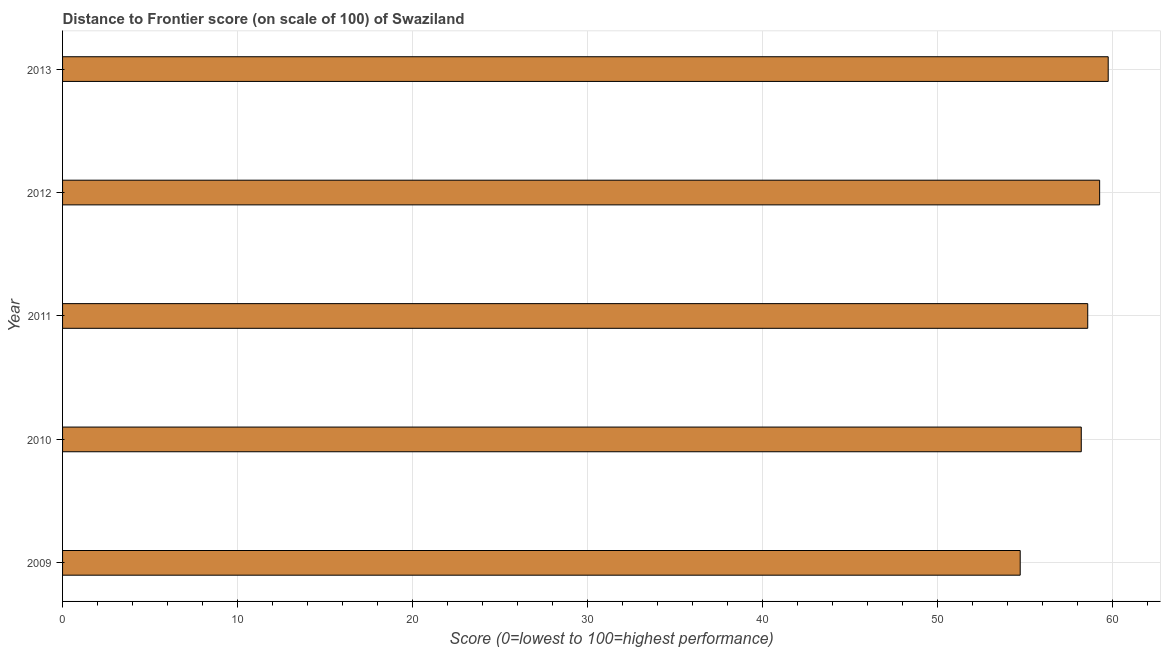Does the graph contain any zero values?
Make the answer very short. No. Does the graph contain grids?
Ensure brevity in your answer.  Yes. What is the title of the graph?
Provide a short and direct response. Distance to Frontier score (on scale of 100) of Swaziland. What is the label or title of the X-axis?
Provide a short and direct response. Score (0=lowest to 100=highest performance). What is the distance to frontier score in 2013?
Make the answer very short. 59.76. Across all years, what is the maximum distance to frontier score?
Offer a terse response. 59.76. Across all years, what is the minimum distance to frontier score?
Give a very brief answer. 54.73. In which year was the distance to frontier score maximum?
Your answer should be very brief. 2013. In which year was the distance to frontier score minimum?
Make the answer very short. 2009. What is the sum of the distance to frontier score?
Your answer should be very brief. 290.57. What is the difference between the distance to frontier score in 2010 and 2013?
Offer a very short reply. -1.54. What is the average distance to frontier score per year?
Your answer should be very brief. 58.11. What is the median distance to frontier score?
Your response must be concise. 58.59. Do a majority of the years between 2009 and 2011 (inclusive) have distance to frontier score greater than 28 ?
Provide a succinct answer. Yes. What is the ratio of the distance to frontier score in 2009 to that in 2013?
Provide a short and direct response. 0.92. What is the difference between the highest and the second highest distance to frontier score?
Your answer should be very brief. 0.49. What is the difference between the highest and the lowest distance to frontier score?
Provide a short and direct response. 5.03. In how many years, is the distance to frontier score greater than the average distance to frontier score taken over all years?
Your answer should be compact. 4. Are the values on the major ticks of X-axis written in scientific E-notation?
Offer a very short reply. No. What is the Score (0=lowest to 100=highest performance) of 2009?
Make the answer very short. 54.73. What is the Score (0=lowest to 100=highest performance) in 2010?
Give a very brief answer. 58.22. What is the Score (0=lowest to 100=highest performance) of 2011?
Make the answer very short. 58.59. What is the Score (0=lowest to 100=highest performance) in 2012?
Offer a terse response. 59.27. What is the Score (0=lowest to 100=highest performance) in 2013?
Your answer should be compact. 59.76. What is the difference between the Score (0=lowest to 100=highest performance) in 2009 and 2010?
Provide a short and direct response. -3.49. What is the difference between the Score (0=lowest to 100=highest performance) in 2009 and 2011?
Offer a very short reply. -3.86. What is the difference between the Score (0=lowest to 100=highest performance) in 2009 and 2012?
Your answer should be compact. -4.54. What is the difference between the Score (0=lowest to 100=highest performance) in 2009 and 2013?
Keep it short and to the point. -5.03. What is the difference between the Score (0=lowest to 100=highest performance) in 2010 and 2011?
Provide a succinct answer. -0.37. What is the difference between the Score (0=lowest to 100=highest performance) in 2010 and 2012?
Keep it short and to the point. -1.05. What is the difference between the Score (0=lowest to 100=highest performance) in 2010 and 2013?
Your answer should be compact. -1.54. What is the difference between the Score (0=lowest to 100=highest performance) in 2011 and 2012?
Provide a succinct answer. -0.68. What is the difference between the Score (0=lowest to 100=highest performance) in 2011 and 2013?
Your answer should be very brief. -1.17. What is the difference between the Score (0=lowest to 100=highest performance) in 2012 and 2013?
Make the answer very short. -0.49. What is the ratio of the Score (0=lowest to 100=highest performance) in 2009 to that in 2011?
Your response must be concise. 0.93. What is the ratio of the Score (0=lowest to 100=highest performance) in 2009 to that in 2012?
Your answer should be very brief. 0.92. What is the ratio of the Score (0=lowest to 100=highest performance) in 2009 to that in 2013?
Provide a short and direct response. 0.92. What is the ratio of the Score (0=lowest to 100=highest performance) in 2010 to that in 2012?
Offer a terse response. 0.98. What is the ratio of the Score (0=lowest to 100=highest performance) in 2010 to that in 2013?
Make the answer very short. 0.97. 